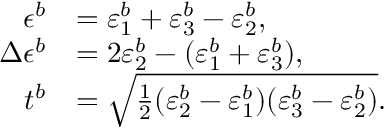Convert formula to latex. <formula><loc_0><loc_0><loc_500><loc_500>\begin{array} { r l } { \epsilon ^ { b } } & { = \varepsilon _ { 1 } ^ { b } + \varepsilon _ { 3 } ^ { b } - \varepsilon _ { 2 } ^ { b } , } \\ { \Delta \epsilon ^ { b } } & { = 2 \varepsilon _ { 2 } ^ { b } - ( \varepsilon _ { 1 } ^ { b } + \varepsilon _ { 3 } ^ { b } ) , } \\ { t ^ { b } } & { = \sqrt { \frac { 1 } { 2 } ( \varepsilon _ { 2 } ^ { b } - \varepsilon _ { 1 } ^ { b } ) ( \varepsilon _ { 3 } ^ { b } - \varepsilon _ { 2 } ^ { b } ) } . } \end{array}</formula> 